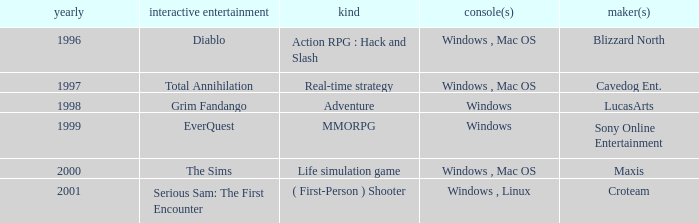What year is the Grim Fandango with a windows platform? 1998.0. 